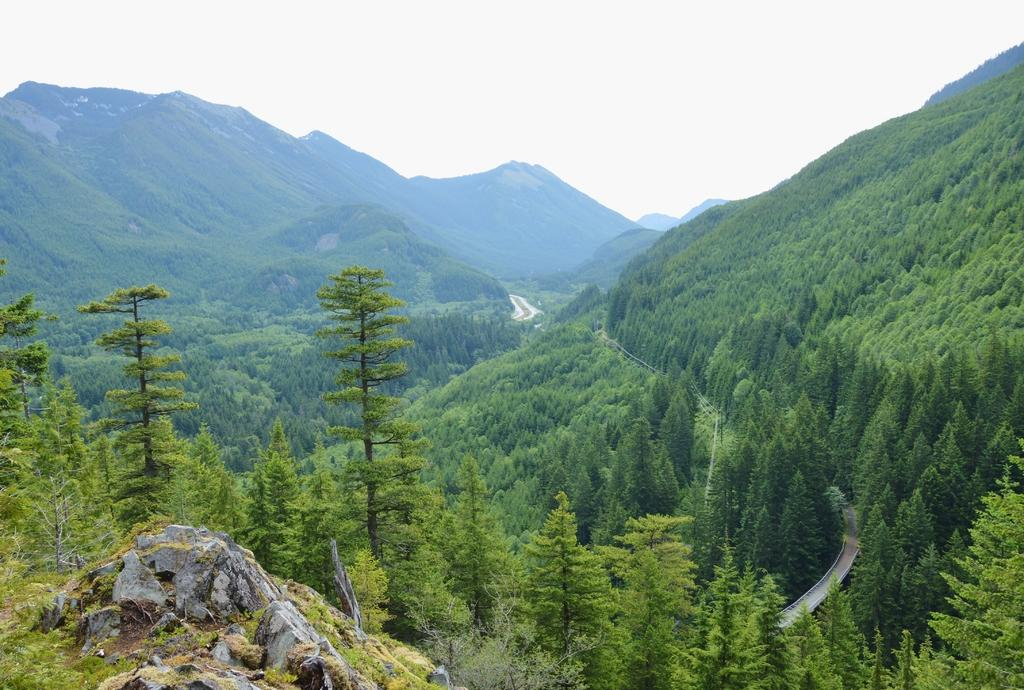What type of natural formation can be seen in the image? There are mountains in the image. What covers the mountains in the image? The mountains are covered with trees. What else can be seen on the right side of the image? There is a road visible on the right side of the image. What is the condition of the sky in the image? The sky is clear in the image. What type of reward is the dog receiving for walking on the road in the image? There is no dog present in the image, and therefore no reward or walking activity can be observed. 